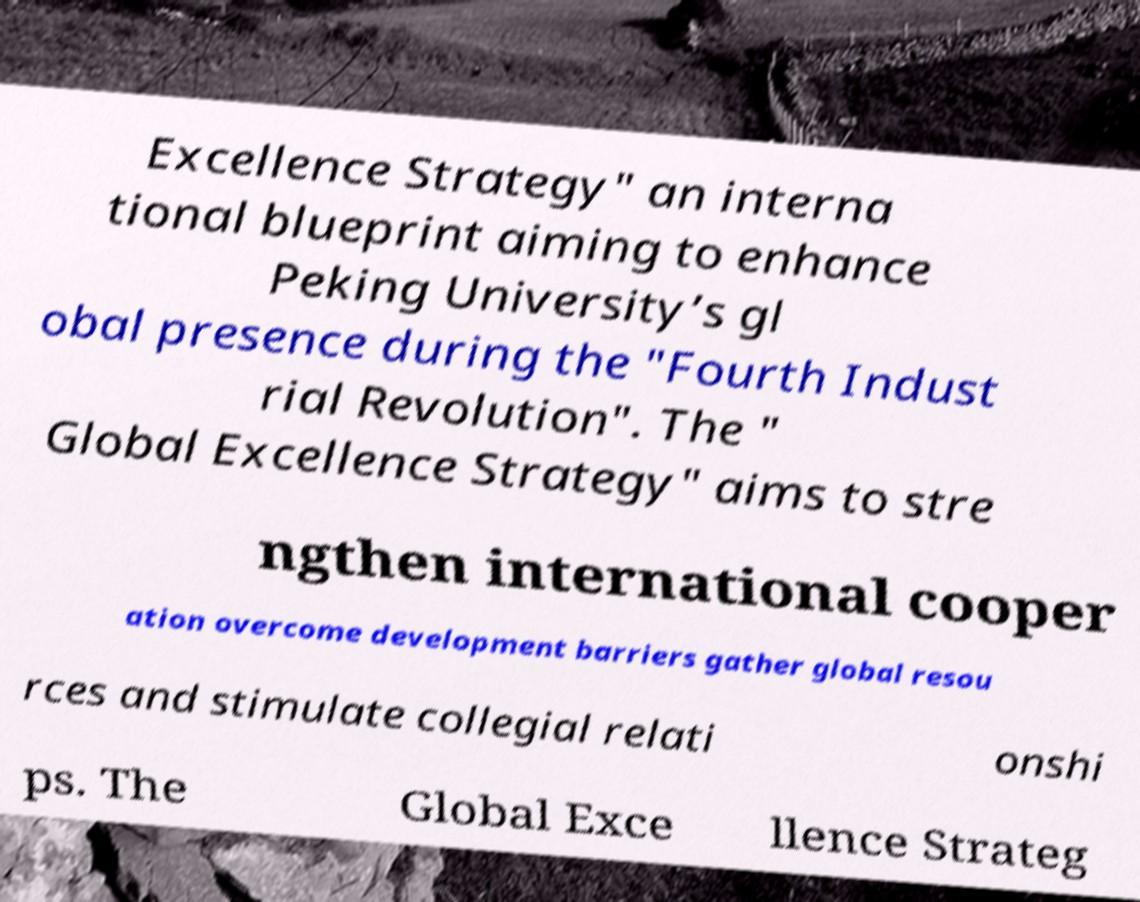Could you assist in decoding the text presented in this image and type it out clearly? Excellence Strategy" an interna tional blueprint aiming to enhance Peking University’s gl obal presence during the "Fourth Indust rial Revolution". The " Global Excellence Strategy" aims to stre ngthen international cooper ation overcome development barriers gather global resou rces and stimulate collegial relati onshi ps. The Global Exce llence Strateg 